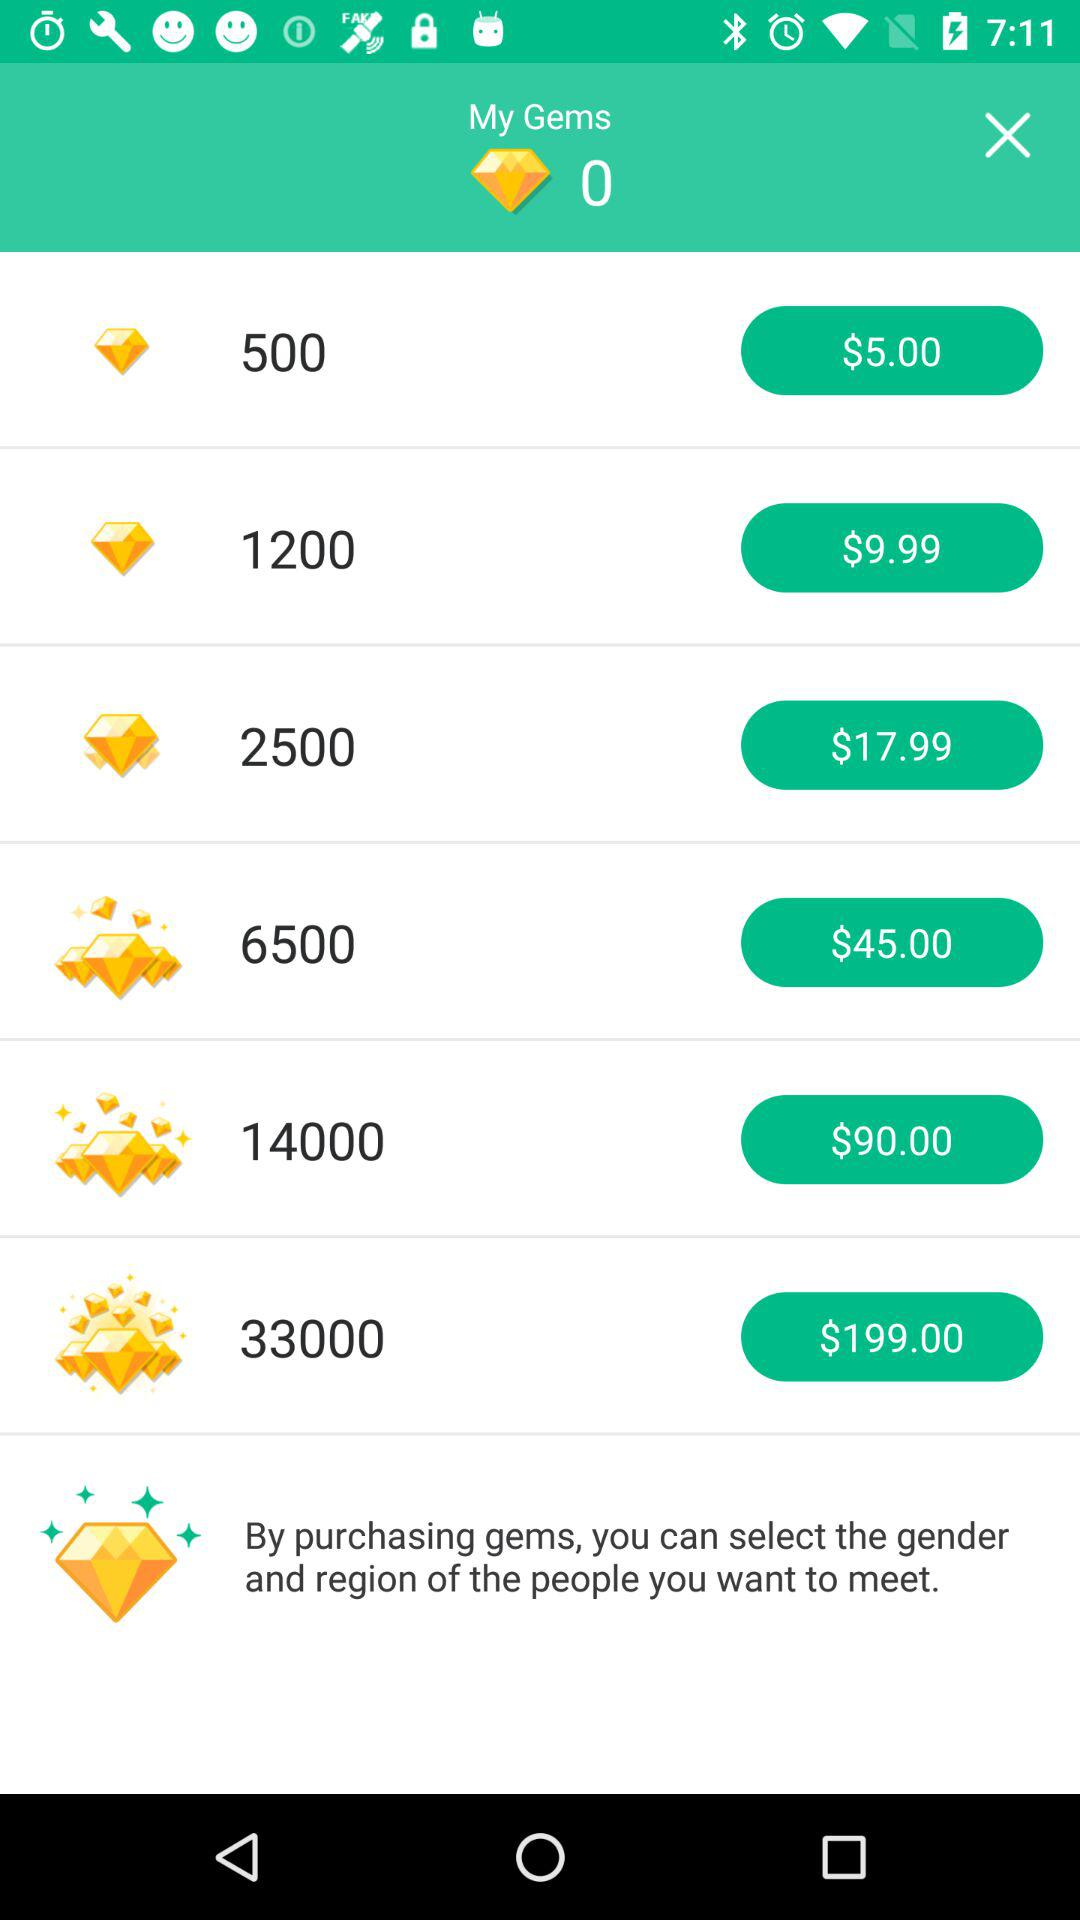How many gems can be purchased for $199.00? For $199.00, 33000 can be purchased. 